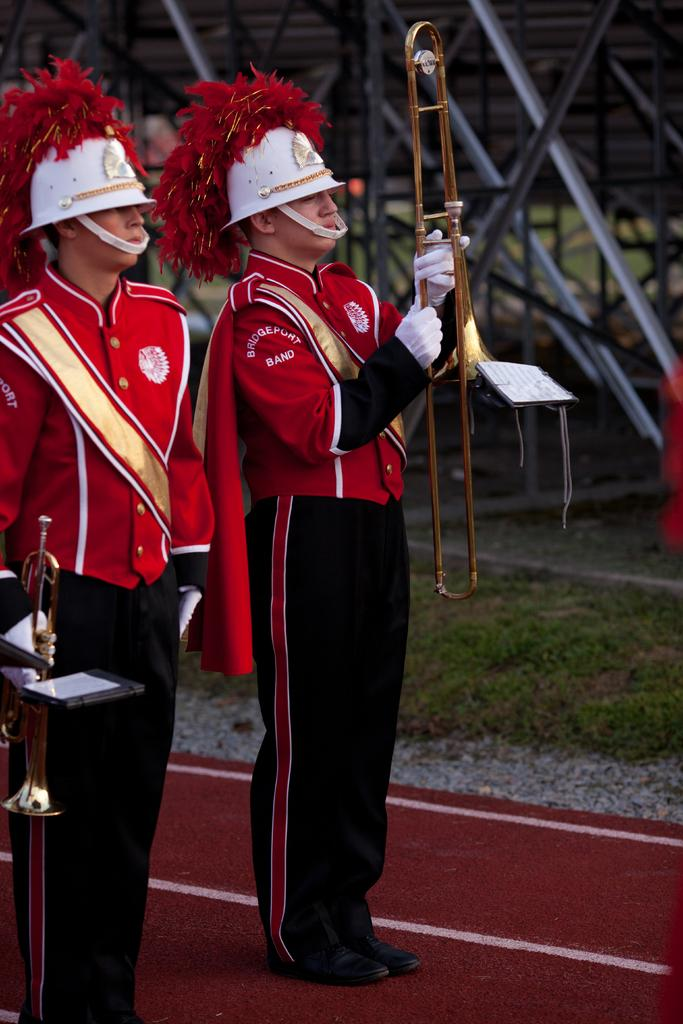<image>
Describe the image concisely. Two band members standing side by side while wearing a jacket that says "BRIDGEPORT BAND". 